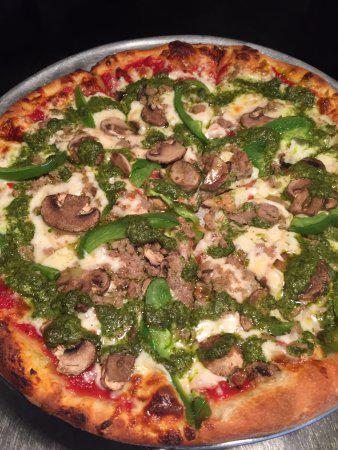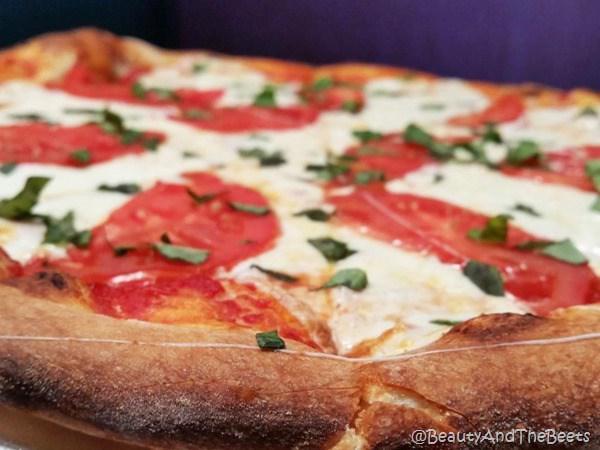The first image is the image on the left, the second image is the image on the right. For the images displayed, is the sentence "Part of a round metal tray is visible between at least two slices of pizza in the right image." factually correct? Answer yes or no. No. The first image is the image on the left, the second image is the image on the right. Given the left and right images, does the statement "There are red peppers on exactly one pizza." hold true? Answer yes or no. No. 